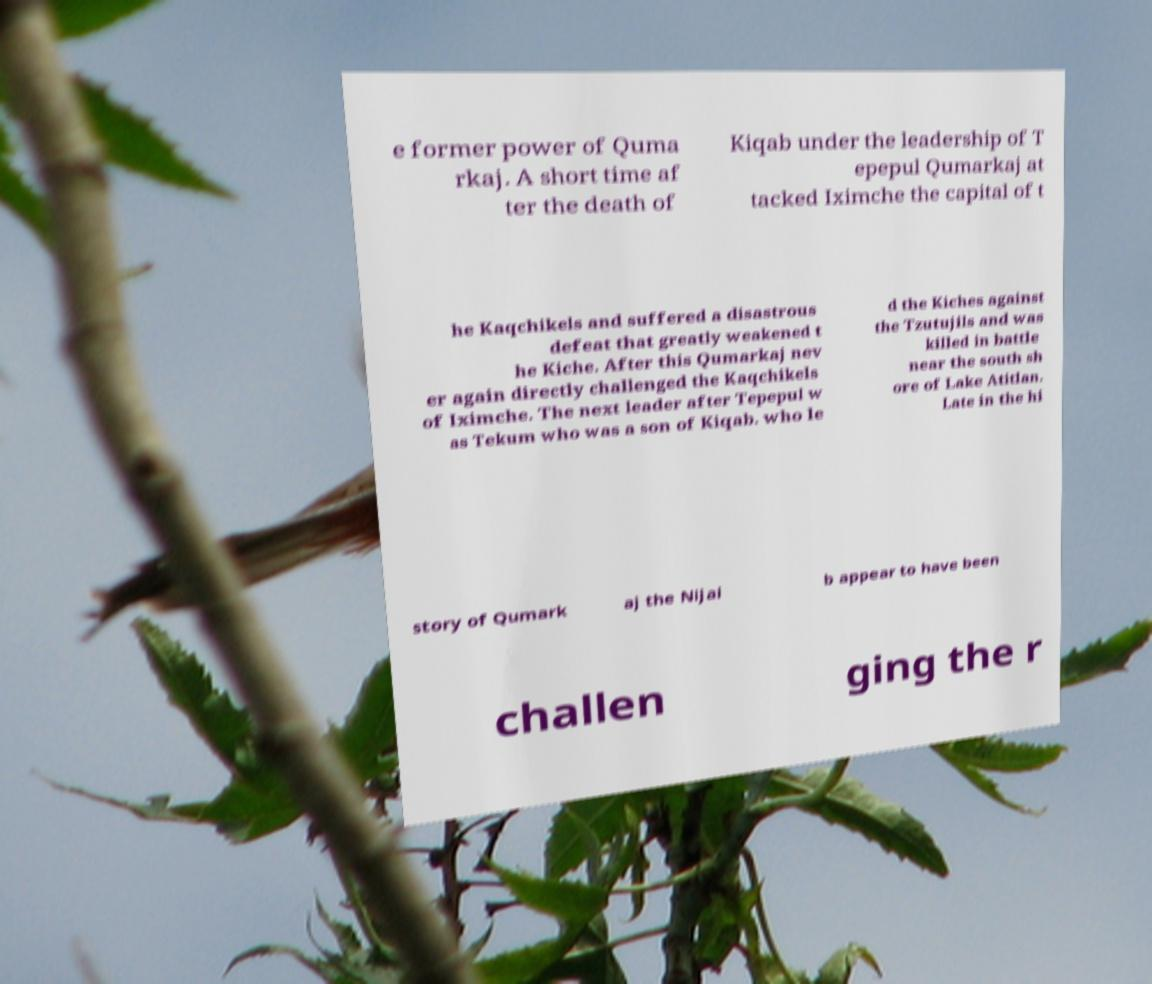There's text embedded in this image that I need extracted. Can you transcribe it verbatim? e former power of Quma rkaj. A short time af ter the death of Kiqab under the leadership of T epepul Qumarkaj at tacked Iximche the capital of t he Kaqchikels and suffered a disastrous defeat that greatly weakened t he Kiche. After this Qumarkaj nev er again directly challenged the Kaqchikels of Iximche. The next leader after Tepepul w as Tekum who was a son of Kiqab. who le d the Kiches against the Tzutujils and was killed in battle near the south sh ore of Lake Atitlan. Late in the hi story of Qumark aj the Nijai b appear to have been challen ging the r 